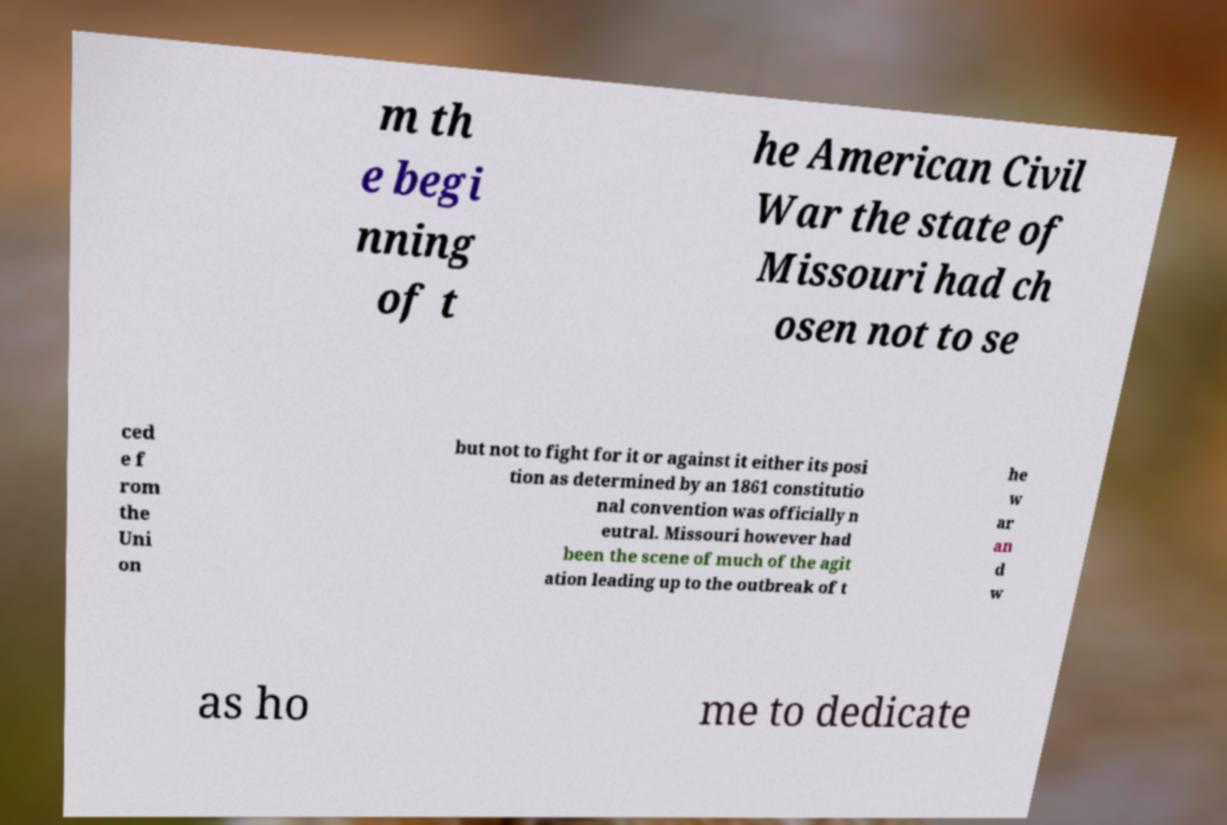There's text embedded in this image that I need extracted. Can you transcribe it verbatim? m th e begi nning of t he American Civil War the state of Missouri had ch osen not to se ced e f rom the Uni on but not to fight for it or against it either its posi tion as determined by an 1861 constitutio nal convention was officially n eutral. Missouri however had been the scene of much of the agit ation leading up to the outbreak of t he w ar an d w as ho me to dedicate 